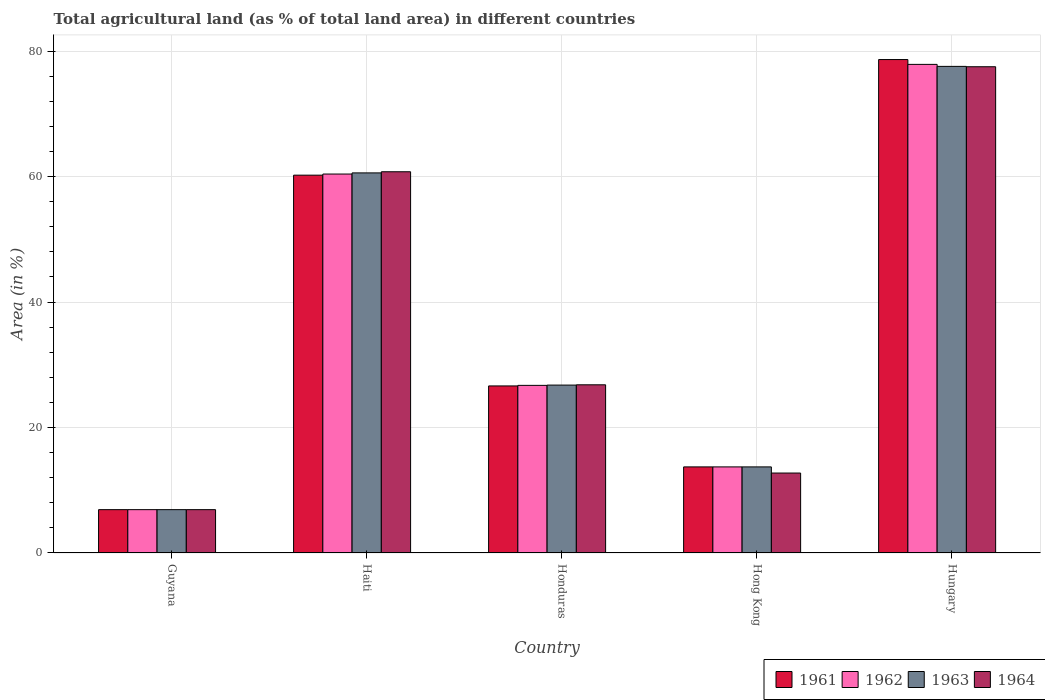How many groups of bars are there?
Your answer should be very brief. 5. Are the number of bars on each tick of the X-axis equal?
Give a very brief answer. Yes. How many bars are there on the 2nd tick from the left?
Give a very brief answer. 4. How many bars are there on the 5th tick from the right?
Provide a succinct answer. 4. What is the label of the 3rd group of bars from the left?
Your answer should be compact. Honduras. What is the percentage of agricultural land in 1963 in Honduras?
Offer a very short reply. 26.77. Across all countries, what is the maximum percentage of agricultural land in 1962?
Provide a short and direct response. 77.89. Across all countries, what is the minimum percentage of agricultural land in 1962?
Offer a terse response. 6.91. In which country was the percentage of agricultural land in 1963 maximum?
Give a very brief answer. Hungary. In which country was the percentage of agricultural land in 1962 minimum?
Your response must be concise. Guyana. What is the total percentage of agricultural land in 1964 in the graph?
Keep it short and to the point. 184.76. What is the difference between the percentage of agricultural land in 1962 in Guyana and that in Hungary?
Make the answer very short. -70.99. What is the difference between the percentage of agricultural land in 1962 in Guyana and the percentage of agricultural land in 1961 in Hong Kong?
Give a very brief answer. -6.82. What is the average percentage of agricultural land in 1961 per country?
Provide a short and direct response. 37.23. What is the difference between the percentage of agricultural land of/in 1963 and percentage of agricultural land of/in 1964 in Haiti?
Your response must be concise. -0.18. What is the ratio of the percentage of agricultural land in 1961 in Haiti to that in Hong Kong?
Offer a very short reply. 4.39. What is the difference between the highest and the second highest percentage of agricultural land in 1961?
Keep it short and to the point. -33.6. What is the difference between the highest and the lowest percentage of agricultural land in 1963?
Offer a terse response. 70.67. In how many countries, is the percentage of agricultural land in 1962 greater than the average percentage of agricultural land in 1962 taken over all countries?
Make the answer very short. 2. What does the 1st bar from the right in Hungary represents?
Ensure brevity in your answer.  1964. How many bars are there?
Provide a short and direct response. 20. Are all the bars in the graph horizontal?
Offer a very short reply. No. What is the difference between two consecutive major ticks on the Y-axis?
Provide a succinct answer. 20. Are the values on the major ticks of Y-axis written in scientific E-notation?
Offer a very short reply. No. Does the graph contain any zero values?
Your answer should be very brief. No. Does the graph contain grids?
Keep it short and to the point. Yes. What is the title of the graph?
Offer a terse response. Total agricultural land (as % of total land area) in different countries. Does "1990" appear as one of the legend labels in the graph?
Keep it short and to the point. No. What is the label or title of the Y-axis?
Your response must be concise. Area (in %). What is the Area (in %) in 1961 in Guyana?
Provide a succinct answer. 6.91. What is the Area (in %) of 1962 in Guyana?
Offer a very short reply. 6.91. What is the Area (in %) in 1963 in Guyana?
Provide a succinct answer. 6.91. What is the Area (in %) of 1964 in Guyana?
Provide a short and direct response. 6.91. What is the Area (in %) in 1961 in Haiti?
Provide a short and direct response. 60.23. What is the Area (in %) of 1962 in Haiti?
Your answer should be very brief. 60.41. What is the Area (in %) in 1963 in Haiti?
Ensure brevity in your answer.  60.6. What is the Area (in %) in 1964 in Haiti?
Keep it short and to the point. 60.78. What is the Area (in %) of 1961 in Honduras?
Provide a short and direct response. 26.63. What is the Area (in %) of 1962 in Honduras?
Offer a very short reply. 26.72. What is the Area (in %) of 1963 in Honduras?
Provide a short and direct response. 26.77. What is the Area (in %) in 1964 in Honduras?
Your answer should be compact. 26.81. What is the Area (in %) in 1961 in Hong Kong?
Give a very brief answer. 13.73. What is the Area (in %) in 1962 in Hong Kong?
Keep it short and to the point. 13.73. What is the Area (in %) in 1963 in Hong Kong?
Your answer should be compact. 13.73. What is the Area (in %) of 1964 in Hong Kong?
Make the answer very short. 12.75. What is the Area (in %) in 1961 in Hungary?
Your answer should be compact. 78.67. What is the Area (in %) of 1962 in Hungary?
Provide a succinct answer. 77.89. What is the Area (in %) of 1963 in Hungary?
Make the answer very short. 77.57. What is the Area (in %) of 1964 in Hungary?
Provide a succinct answer. 77.52. Across all countries, what is the maximum Area (in %) of 1961?
Provide a succinct answer. 78.67. Across all countries, what is the maximum Area (in %) in 1962?
Provide a short and direct response. 77.89. Across all countries, what is the maximum Area (in %) of 1963?
Keep it short and to the point. 77.57. Across all countries, what is the maximum Area (in %) of 1964?
Your response must be concise. 77.52. Across all countries, what is the minimum Area (in %) of 1961?
Provide a short and direct response. 6.91. Across all countries, what is the minimum Area (in %) of 1962?
Offer a very short reply. 6.91. Across all countries, what is the minimum Area (in %) of 1963?
Offer a very short reply. 6.91. Across all countries, what is the minimum Area (in %) in 1964?
Provide a succinct answer. 6.91. What is the total Area (in %) in 1961 in the graph?
Offer a terse response. 186.16. What is the total Area (in %) of 1962 in the graph?
Ensure brevity in your answer.  185.66. What is the total Area (in %) in 1963 in the graph?
Your response must be concise. 185.57. What is the total Area (in %) of 1964 in the graph?
Your answer should be compact. 184.76. What is the difference between the Area (in %) in 1961 in Guyana and that in Haiti?
Make the answer very short. -53.32. What is the difference between the Area (in %) in 1962 in Guyana and that in Haiti?
Your answer should be very brief. -53.51. What is the difference between the Area (in %) of 1963 in Guyana and that in Haiti?
Provide a short and direct response. -53.69. What is the difference between the Area (in %) in 1964 in Guyana and that in Haiti?
Your response must be concise. -53.87. What is the difference between the Area (in %) of 1961 in Guyana and that in Honduras?
Keep it short and to the point. -19.72. What is the difference between the Area (in %) of 1962 in Guyana and that in Honduras?
Your answer should be very brief. -19.81. What is the difference between the Area (in %) of 1963 in Guyana and that in Honduras?
Provide a succinct answer. -19.86. What is the difference between the Area (in %) of 1964 in Guyana and that in Honduras?
Your answer should be compact. -19.9. What is the difference between the Area (in %) of 1961 in Guyana and that in Hong Kong?
Make the answer very short. -6.82. What is the difference between the Area (in %) of 1962 in Guyana and that in Hong Kong?
Give a very brief answer. -6.82. What is the difference between the Area (in %) in 1963 in Guyana and that in Hong Kong?
Make the answer very short. -6.82. What is the difference between the Area (in %) of 1964 in Guyana and that in Hong Kong?
Keep it short and to the point. -5.84. What is the difference between the Area (in %) of 1961 in Guyana and that in Hungary?
Provide a short and direct response. -71.76. What is the difference between the Area (in %) in 1962 in Guyana and that in Hungary?
Your answer should be compact. -70.99. What is the difference between the Area (in %) in 1963 in Guyana and that in Hungary?
Ensure brevity in your answer.  -70.67. What is the difference between the Area (in %) of 1964 in Guyana and that in Hungary?
Your answer should be compact. -70.61. What is the difference between the Area (in %) in 1961 in Haiti and that in Honduras?
Provide a succinct answer. 33.6. What is the difference between the Area (in %) of 1962 in Haiti and that in Honduras?
Keep it short and to the point. 33.69. What is the difference between the Area (in %) of 1963 in Haiti and that in Honduras?
Provide a succinct answer. 33.83. What is the difference between the Area (in %) of 1964 in Haiti and that in Honduras?
Give a very brief answer. 33.96. What is the difference between the Area (in %) of 1961 in Haiti and that in Hong Kong?
Provide a short and direct response. 46.51. What is the difference between the Area (in %) in 1962 in Haiti and that in Hong Kong?
Your response must be concise. 46.69. What is the difference between the Area (in %) in 1963 in Haiti and that in Hong Kong?
Keep it short and to the point. 46.87. What is the difference between the Area (in %) in 1964 in Haiti and that in Hong Kong?
Give a very brief answer. 48.03. What is the difference between the Area (in %) in 1961 in Haiti and that in Hungary?
Your answer should be very brief. -18.43. What is the difference between the Area (in %) of 1962 in Haiti and that in Hungary?
Your response must be concise. -17.48. What is the difference between the Area (in %) of 1963 in Haiti and that in Hungary?
Your answer should be very brief. -16.98. What is the difference between the Area (in %) of 1964 in Haiti and that in Hungary?
Your response must be concise. -16.74. What is the difference between the Area (in %) in 1961 in Honduras and that in Hong Kong?
Provide a short and direct response. 12.91. What is the difference between the Area (in %) in 1962 in Honduras and that in Hong Kong?
Your answer should be compact. 13. What is the difference between the Area (in %) in 1963 in Honduras and that in Hong Kong?
Give a very brief answer. 13.04. What is the difference between the Area (in %) in 1964 in Honduras and that in Hong Kong?
Your response must be concise. 14.07. What is the difference between the Area (in %) of 1961 in Honduras and that in Hungary?
Your response must be concise. -52.03. What is the difference between the Area (in %) in 1962 in Honduras and that in Hungary?
Ensure brevity in your answer.  -51.17. What is the difference between the Area (in %) in 1963 in Honduras and that in Hungary?
Ensure brevity in your answer.  -50.81. What is the difference between the Area (in %) of 1964 in Honduras and that in Hungary?
Your response must be concise. -50.71. What is the difference between the Area (in %) in 1961 in Hong Kong and that in Hungary?
Offer a very short reply. -64.94. What is the difference between the Area (in %) in 1962 in Hong Kong and that in Hungary?
Make the answer very short. -64.17. What is the difference between the Area (in %) in 1963 in Hong Kong and that in Hungary?
Ensure brevity in your answer.  -63.85. What is the difference between the Area (in %) of 1964 in Hong Kong and that in Hungary?
Offer a very short reply. -64.77. What is the difference between the Area (in %) of 1961 in Guyana and the Area (in %) of 1962 in Haiti?
Make the answer very short. -53.51. What is the difference between the Area (in %) in 1961 in Guyana and the Area (in %) in 1963 in Haiti?
Provide a short and direct response. -53.69. What is the difference between the Area (in %) of 1961 in Guyana and the Area (in %) of 1964 in Haiti?
Give a very brief answer. -53.87. What is the difference between the Area (in %) in 1962 in Guyana and the Area (in %) in 1963 in Haiti?
Your answer should be compact. -53.69. What is the difference between the Area (in %) of 1962 in Guyana and the Area (in %) of 1964 in Haiti?
Provide a short and direct response. -53.87. What is the difference between the Area (in %) in 1963 in Guyana and the Area (in %) in 1964 in Haiti?
Your answer should be very brief. -53.87. What is the difference between the Area (in %) in 1961 in Guyana and the Area (in %) in 1962 in Honduras?
Your answer should be very brief. -19.81. What is the difference between the Area (in %) of 1961 in Guyana and the Area (in %) of 1963 in Honduras?
Your response must be concise. -19.86. What is the difference between the Area (in %) in 1961 in Guyana and the Area (in %) in 1964 in Honduras?
Offer a terse response. -19.9. What is the difference between the Area (in %) of 1962 in Guyana and the Area (in %) of 1963 in Honduras?
Make the answer very short. -19.86. What is the difference between the Area (in %) of 1962 in Guyana and the Area (in %) of 1964 in Honduras?
Keep it short and to the point. -19.9. What is the difference between the Area (in %) of 1963 in Guyana and the Area (in %) of 1964 in Honduras?
Make the answer very short. -19.9. What is the difference between the Area (in %) in 1961 in Guyana and the Area (in %) in 1962 in Hong Kong?
Keep it short and to the point. -6.82. What is the difference between the Area (in %) in 1961 in Guyana and the Area (in %) in 1963 in Hong Kong?
Offer a very short reply. -6.82. What is the difference between the Area (in %) in 1961 in Guyana and the Area (in %) in 1964 in Hong Kong?
Your answer should be compact. -5.84. What is the difference between the Area (in %) of 1962 in Guyana and the Area (in %) of 1963 in Hong Kong?
Give a very brief answer. -6.82. What is the difference between the Area (in %) in 1962 in Guyana and the Area (in %) in 1964 in Hong Kong?
Your response must be concise. -5.84. What is the difference between the Area (in %) of 1963 in Guyana and the Area (in %) of 1964 in Hong Kong?
Offer a very short reply. -5.84. What is the difference between the Area (in %) of 1961 in Guyana and the Area (in %) of 1962 in Hungary?
Your answer should be very brief. -70.99. What is the difference between the Area (in %) of 1961 in Guyana and the Area (in %) of 1963 in Hungary?
Your response must be concise. -70.67. What is the difference between the Area (in %) in 1961 in Guyana and the Area (in %) in 1964 in Hungary?
Offer a terse response. -70.61. What is the difference between the Area (in %) of 1962 in Guyana and the Area (in %) of 1963 in Hungary?
Your answer should be very brief. -70.67. What is the difference between the Area (in %) of 1962 in Guyana and the Area (in %) of 1964 in Hungary?
Provide a succinct answer. -70.61. What is the difference between the Area (in %) of 1963 in Guyana and the Area (in %) of 1964 in Hungary?
Offer a very short reply. -70.61. What is the difference between the Area (in %) of 1961 in Haiti and the Area (in %) of 1962 in Honduras?
Your answer should be very brief. 33.51. What is the difference between the Area (in %) of 1961 in Haiti and the Area (in %) of 1963 in Honduras?
Give a very brief answer. 33.46. What is the difference between the Area (in %) in 1961 in Haiti and the Area (in %) in 1964 in Honduras?
Offer a very short reply. 33.42. What is the difference between the Area (in %) of 1962 in Haiti and the Area (in %) of 1963 in Honduras?
Your answer should be very brief. 33.65. What is the difference between the Area (in %) in 1962 in Haiti and the Area (in %) in 1964 in Honduras?
Your answer should be compact. 33.6. What is the difference between the Area (in %) in 1963 in Haiti and the Area (in %) in 1964 in Honduras?
Keep it short and to the point. 33.78. What is the difference between the Area (in %) in 1961 in Haiti and the Area (in %) in 1962 in Hong Kong?
Your answer should be compact. 46.51. What is the difference between the Area (in %) in 1961 in Haiti and the Area (in %) in 1963 in Hong Kong?
Ensure brevity in your answer.  46.51. What is the difference between the Area (in %) of 1961 in Haiti and the Area (in %) of 1964 in Hong Kong?
Provide a succinct answer. 47.49. What is the difference between the Area (in %) in 1962 in Haiti and the Area (in %) in 1963 in Hong Kong?
Provide a short and direct response. 46.69. What is the difference between the Area (in %) in 1962 in Haiti and the Area (in %) in 1964 in Hong Kong?
Provide a succinct answer. 47.67. What is the difference between the Area (in %) in 1963 in Haiti and the Area (in %) in 1964 in Hong Kong?
Offer a very short reply. 47.85. What is the difference between the Area (in %) in 1961 in Haiti and the Area (in %) in 1962 in Hungary?
Give a very brief answer. -17.66. What is the difference between the Area (in %) of 1961 in Haiti and the Area (in %) of 1963 in Hungary?
Give a very brief answer. -17.34. What is the difference between the Area (in %) in 1961 in Haiti and the Area (in %) in 1964 in Hungary?
Offer a terse response. -17.29. What is the difference between the Area (in %) of 1962 in Haiti and the Area (in %) of 1963 in Hungary?
Your answer should be compact. -17.16. What is the difference between the Area (in %) of 1962 in Haiti and the Area (in %) of 1964 in Hungary?
Your answer should be compact. -17.11. What is the difference between the Area (in %) in 1963 in Haiti and the Area (in %) in 1964 in Hungary?
Your response must be concise. -16.92. What is the difference between the Area (in %) in 1961 in Honduras and the Area (in %) in 1962 in Hong Kong?
Provide a short and direct response. 12.91. What is the difference between the Area (in %) of 1961 in Honduras and the Area (in %) of 1963 in Hong Kong?
Give a very brief answer. 12.91. What is the difference between the Area (in %) of 1961 in Honduras and the Area (in %) of 1964 in Hong Kong?
Provide a short and direct response. 13.89. What is the difference between the Area (in %) of 1962 in Honduras and the Area (in %) of 1963 in Hong Kong?
Make the answer very short. 13. What is the difference between the Area (in %) of 1962 in Honduras and the Area (in %) of 1964 in Hong Kong?
Provide a succinct answer. 13.98. What is the difference between the Area (in %) in 1963 in Honduras and the Area (in %) in 1964 in Hong Kong?
Ensure brevity in your answer.  14.02. What is the difference between the Area (in %) of 1961 in Honduras and the Area (in %) of 1962 in Hungary?
Provide a succinct answer. -51.26. What is the difference between the Area (in %) in 1961 in Honduras and the Area (in %) in 1963 in Hungary?
Provide a short and direct response. -50.94. What is the difference between the Area (in %) in 1961 in Honduras and the Area (in %) in 1964 in Hungary?
Your response must be concise. -50.89. What is the difference between the Area (in %) in 1962 in Honduras and the Area (in %) in 1963 in Hungary?
Ensure brevity in your answer.  -50.85. What is the difference between the Area (in %) in 1962 in Honduras and the Area (in %) in 1964 in Hungary?
Your answer should be very brief. -50.8. What is the difference between the Area (in %) in 1963 in Honduras and the Area (in %) in 1964 in Hungary?
Keep it short and to the point. -50.75. What is the difference between the Area (in %) in 1961 in Hong Kong and the Area (in %) in 1962 in Hungary?
Your answer should be compact. -64.17. What is the difference between the Area (in %) of 1961 in Hong Kong and the Area (in %) of 1963 in Hungary?
Ensure brevity in your answer.  -63.85. What is the difference between the Area (in %) of 1961 in Hong Kong and the Area (in %) of 1964 in Hungary?
Provide a short and direct response. -63.79. What is the difference between the Area (in %) of 1962 in Hong Kong and the Area (in %) of 1963 in Hungary?
Your answer should be compact. -63.85. What is the difference between the Area (in %) of 1962 in Hong Kong and the Area (in %) of 1964 in Hungary?
Offer a terse response. -63.79. What is the difference between the Area (in %) in 1963 in Hong Kong and the Area (in %) in 1964 in Hungary?
Your answer should be very brief. -63.79. What is the average Area (in %) of 1961 per country?
Provide a short and direct response. 37.23. What is the average Area (in %) of 1962 per country?
Offer a very short reply. 37.13. What is the average Area (in %) of 1963 per country?
Your answer should be compact. 37.11. What is the average Area (in %) in 1964 per country?
Ensure brevity in your answer.  36.95. What is the difference between the Area (in %) in 1961 and Area (in %) in 1962 in Guyana?
Provide a succinct answer. 0. What is the difference between the Area (in %) in 1961 and Area (in %) in 1963 in Guyana?
Make the answer very short. 0. What is the difference between the Area (in %) of 1961 and Area (in %) of 1964 in Guyana?
Offer a very short reply. 0. What is the difference between the Area (in %) of 1961 and Area (in %) of 1962 in Haiti?
Offer a very short reply. -0.18. What is the difference between the Area (in %) in 1961 and Area (in %) in 1963 in Haiti?
Offer a very short reply. -0.36. What is the difference between the Area (in %) of 1961 and Area (in %) of 1964 in Haiti?
Provide a succinct answer. -0.54. What is the difference between the Area (in %) in 1962 and Area (in %) in 1963 in Haiti?
Your answer should be very brief. -0.18. What is the difference between the Area (in %) of 1962 and Area (in %) of 1964 in Haiti?
Keep it short and to the point. -0.36. What is the difference between the Area (in %) in 1963 and Area (in %) in 1964 in Haiti?
Offer a very short reply. -0.18. What is the difference between the Area (in %) of 1961 and Area (in %) of 1962 in Honduras?
Provide a succinct answer. -0.09. What is the difference between the Area (in %) of 1961 and Area (in %) of 1963 in Honduras?
Offer a terse response. -0.13. What is the difference between the Area (in %) of 1961 and Area (in %) of 1964 in Honduras?
Ensure brevity in your answer.  -0.18. What is the difference between the Area (in %) in 1962 and Area (in %) in 1963 in Honduras?
Your answer should be compact. -0.04. What is the difference between the Area (in %) in 1962 and Area (in %) in 1964 in Honduras?
Your answer should be very brief. -0.09. What is the difference between the Area (in %) in 1963 and Area (in %) in 1964 in Honduras?
Ensure brevity in your answer.  -0.04. What is the difference between the Area (in %) in 1961 and Area (in %) in 1962 in Hong Kong?
Keep it short and to the point. 0. What is the difference between the Area (in %) of 1961 and Area (in %) of 1963 in Hong Kong?
Offer a terse response. 0. What is the difference between the Area (in %) of 1961 and Area (in %) of 1964 in Hong Kong?
Offer a very short reply. 0.98. What is the difference between the Area (in %) in 1962 and Area (in %) in 1963 in Hong Kong?
Offer a terse response. 0. What is the difference between the Area (in %) of 1962 and Area (in %) of 1964 in Hong Kong?
Offer a very short reply. 0.98. What is the difference between the Area (in %) of 1963 and Area (in %) of 1964 in Hong Kong?
Make the answer very short. 0.98. What is the difference between the Area (in %) of 1961 and Area (in %) of 1962 in Hungary?
Keep it short and to the point. 0.77. What is the difference between the Area (in %) of 1961 and Area (in %) of 1963 in Hungary?
Provide a succinct answer. 1.09. What is the difference between the Area (in %) of 1961 and Area (in %) of 1964 in Hungary?
Your answer should be compact. 1.15. What is the difference between the Area (in %) in 1962 and Area (in %) in 1963 in Hungary?
Keep it short and to the point. 0.32. What is the difference between the Area (in %) in 1962 and Area (in %) in 1964 in Hungary?
Ensure brevity in your answer.  0.38. What is the difference between the Area (in %) in 1963 and Area (in %) in 1964 in Hungary?
Offer a very short reply. 0.06. What is the ratio of the Area (in %) in 1961 in Guyana to that in Haiti?
Keep it short and to the point. 0.11. What is the ratio of the Area (in %) in 1962 in Guyana to that in Haiti?
Provide a short and direct response. 0.11. What is the ratio of the Area (in %) of 1963 in Guyana to that in Haiti?
Offer a terse response. 0.11. What is the ratio of the Area (in %) in 1964 in Guyana to that in Haiti?
Provide a succinct answer. 0.11. What is the ratio of the Area (in %) in 1961 in Guyana to that in Honduras?
Make the answer very short. 0.26. What is the ratio of the Area (in %) of 1962 in Guyana to that in Honduras?
Provide a short and direct response. 0.26. What is the ratio of the Area (in %) of 1963 in Guyana to that in Honduras?
Give a very brief answer. 0.26. What is the ratio of the Area (in %) of 1964 in Guyana to that in Honduras?
Offer a terse response. 0.26. What is the ratio of the Area (in %) in 1961 in Guyana to that in Hong Kong?
Provide a short and direct response. 0.5. What is the ratio of the Area (in %) in 1962 in Guyana to that in Hong Kong?
Offer a terse response. 0.5. What is the ratio of the Area (in %) of 1963 in Guyana to that in Hong Kong?
Keep it short and to the point. 0.5. What is the ratio of the Area (in %) of 1964 in Guyana to that in Hong Kong?
Your answer should be compact. 0.54. What is the ratio of the Area (in %) in 1961 in Guyana to that in Hungary?
Keep it short and to the point. 0.09. What is the ratio of the Area (in %) in 1962 in Guyana to that in Hungary?
Keep it short and to the point. 0.09. What is the ratio of the Area (in %) of 1963 in Guyana to that in Hungary?
Offer a very short reply. 0.09. What is the ratio of the Area (in %) of 1964 in Guyana to that in Hungary?
Provide a succinct answer. 0.09. What is the ratio of the Area (in %) in 1961 in Haiti to that in Honduras?
Offer a very short reply. 2.26. What is the ratio of the Area (in %) of 1962 in Haiti to that in Honduras?
Offer a very short reply. 2.26. What is the ratio of the Area (in %) of 1963 in Haiti to that in Honduras?
Offer a very short reply. 2.26. What is the ratio of the Area (in %) of 1964 in Haiti to that in Honduras?
Your response must be concise. 2.27. What is the ratio of the Area (in %) in 1961 in Haiti to that in Hong Kong?
Make the answer very short. 4.39. What is the ratio of the Area (in %) in 1962 in Haiti to that in Hong Kong?
Make the answer very short. 4.4. What is the ratio of the Area (in %) in 1963 in Haiti to that in Hong Kong?
Provide a succinct answer. 4.41. What is the ratio of the Area (in %) of 1964 in Haiti to that in Hong Kong?
Provide a short and direct response. 4.77. What is the ratio of the Area (in %) of 1961 in Haiti to that in Hungary?
Ensure brevity in your answer.  0.77. What is the ratio of the Area (in %) in 1962 in Haiti to that in Hungary?
Your response must be concise. 0.78. What is the ratio of the Area (in %) of 1963 in Haiti to that in Hungary?
Offer a very short reply. 0.78. What is the ratio of the Area (in %) of 1964 in Haiti to that in Hungary?
Your answer should be compact. 0.78. What is the ratio of the Area (in %) of 1961 in Honduras to that in Hong Kong?
Offer a very short reply. 1.94. What is the ratio of the Area (in %) of 1962 in Honduras to that in Hong Kong?
Provide a succinct answer. 1.95. What is the ratio of the Area (in %) of 1963 in Honduras to that in Hong Kong?
Your response must be concise. 1.95. What is the ratio of the Area (in %) in 1964 in Honduras to that in Hong Kong?
Ensure brevity in your answer.  2.1. What is the ratio of the Area (in %) of 1961 in Honduras to that in Hungary?
Your answer should be very brief. 0.34. What is the ratio of the Area (in %) of 1962 in Honduras to that in Hungary?
Provide a succinct answer. 0.34. What is the ratio of the Area (in %) in 1963 in Honduras to that in Hungary?
Ensure brevity in your answer.  0.35. What is the ratio of the Area (in %) of 1964 in Honduras to that in Hungary?
Provide a succinct answer. 0.35. What is the ratio of the Area (in %) of 1961 in Hong Kong to that in Hungary?
Provide a succinct answer. 0.17. What is the ratio of the Area (in %) in 1962 in Hong Kong to that in Hungary?
Keep it short and to the point. 0.18. What is the ratio of the Area (in %) of 1963 in Hong Kong to that in Hungary?
Your answer should be very brief. 0.18. What is the ratio of the Area (in %) of 1964 in Hong Kong to that in Hungary?
Provide a short and direct response. 0.16. What is the difference between the highest and the second highest Area (in %) of 1961?
Offer a very short reply. 18.43. What is the difference between the highest and the second highest Area (in %) of 1962?
Your answer should be very brief. 17.48. What is the difference between the highest and the second highest Area (in %) of 1963?
Offer a terse response. 16.98. What is the difference between the highest and the second highest Area (in %) in 1964?
Your response must be concise. 16.74. What is the difference between the highest and the lowest Area (in %) in 1961?
Your response must be concise. 71.76. What is the difference between the highest and the lowest Area (in %) in 1962?
Provide a succinct answer. 70.99. What is the difference between the highest and the lowest Area (in %) in 1963?
Your response must be concise. 70.67. What is the difference between the highest and the lowest Area (in %) in 1964?
Offer a very short reply. 70.61. 